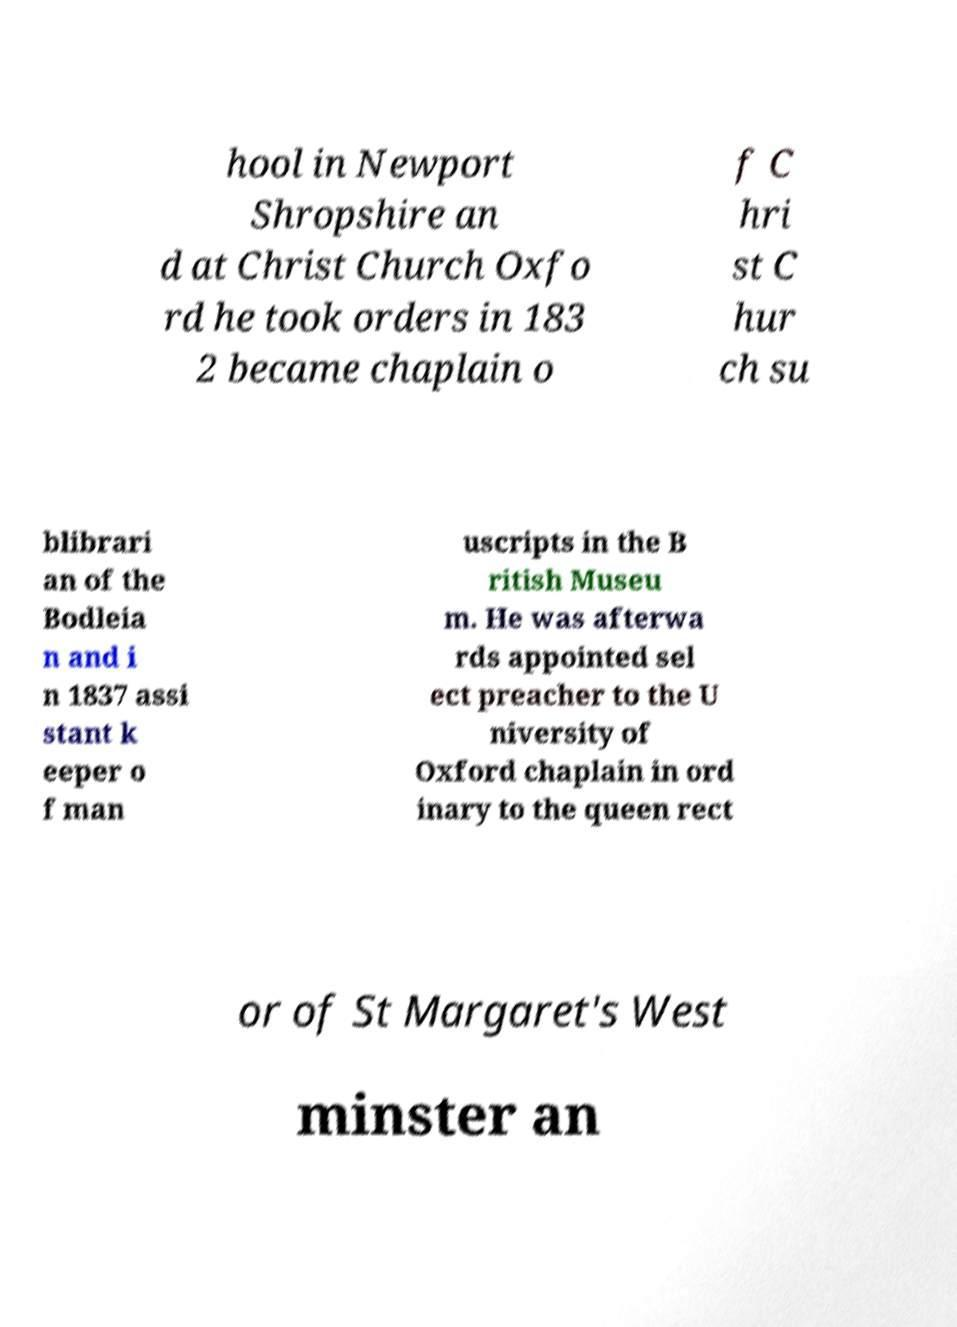Could you assist in decoding the text presented in this image and type it out clearly? hool in Newport Shropshire an d at Christ Church Oxfo rd he took orders in 183 2 became chaplain o f C hri st C hur ch su blibrari an of the Bodleia n and i n 1837 assi stant k eeper o f man uscripts in the B ritish Museu m. He was afterwa rds appointed sel ect preacher to the U niversity of Oxford chaplain in ord inary to the queen rect or of St Margaret's West minster an 